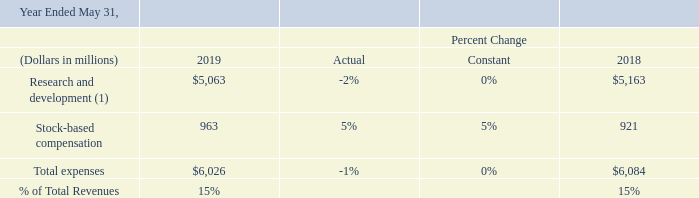Research and Development Expenses: research and development expenses consist primarily of personnel related expenditures. We intend to continue to invest significantly in our research and development efforts because, in our judgment, they are essential to maintaining our competitive position.
(1) Excluding stock-based compensation
On a constant currency basis, total research and development expenses were flat in fiscal 2019, as lower employee related expenses including lower variable compensation were offset by an increase in stock-based compensation expenses .
How much more was the research and development expenses in 2018 compared to 2019?
Answer scale should be: million. 5,163 - 5,063 
Answer: 100. What is the percentage of expenses that went towards stock-based compensation in 2019?
Answer scale should be: percent. 963/6,026 
Answer: 15.98. What was the difference in total expenses in 2019 relative to 2018?
Answer scale should be: million. 6,026 -6,084
Answer: -58. What is the primary component of Research and development expenses? Research and development expenses consist primarily of personnel related expenditures. Does the company intend to continue to invest significantly in Research and Development? We intend to continue to invest significantly in our research and development efforts. Why was the total research and development expenses flat in fiscal 2019? On a constant currency basis, total research and development expenses were flat in fiscal 2019, as lower employee related expenses including lower variable compensation were offset by an increase in stock-based compensation expenses . 